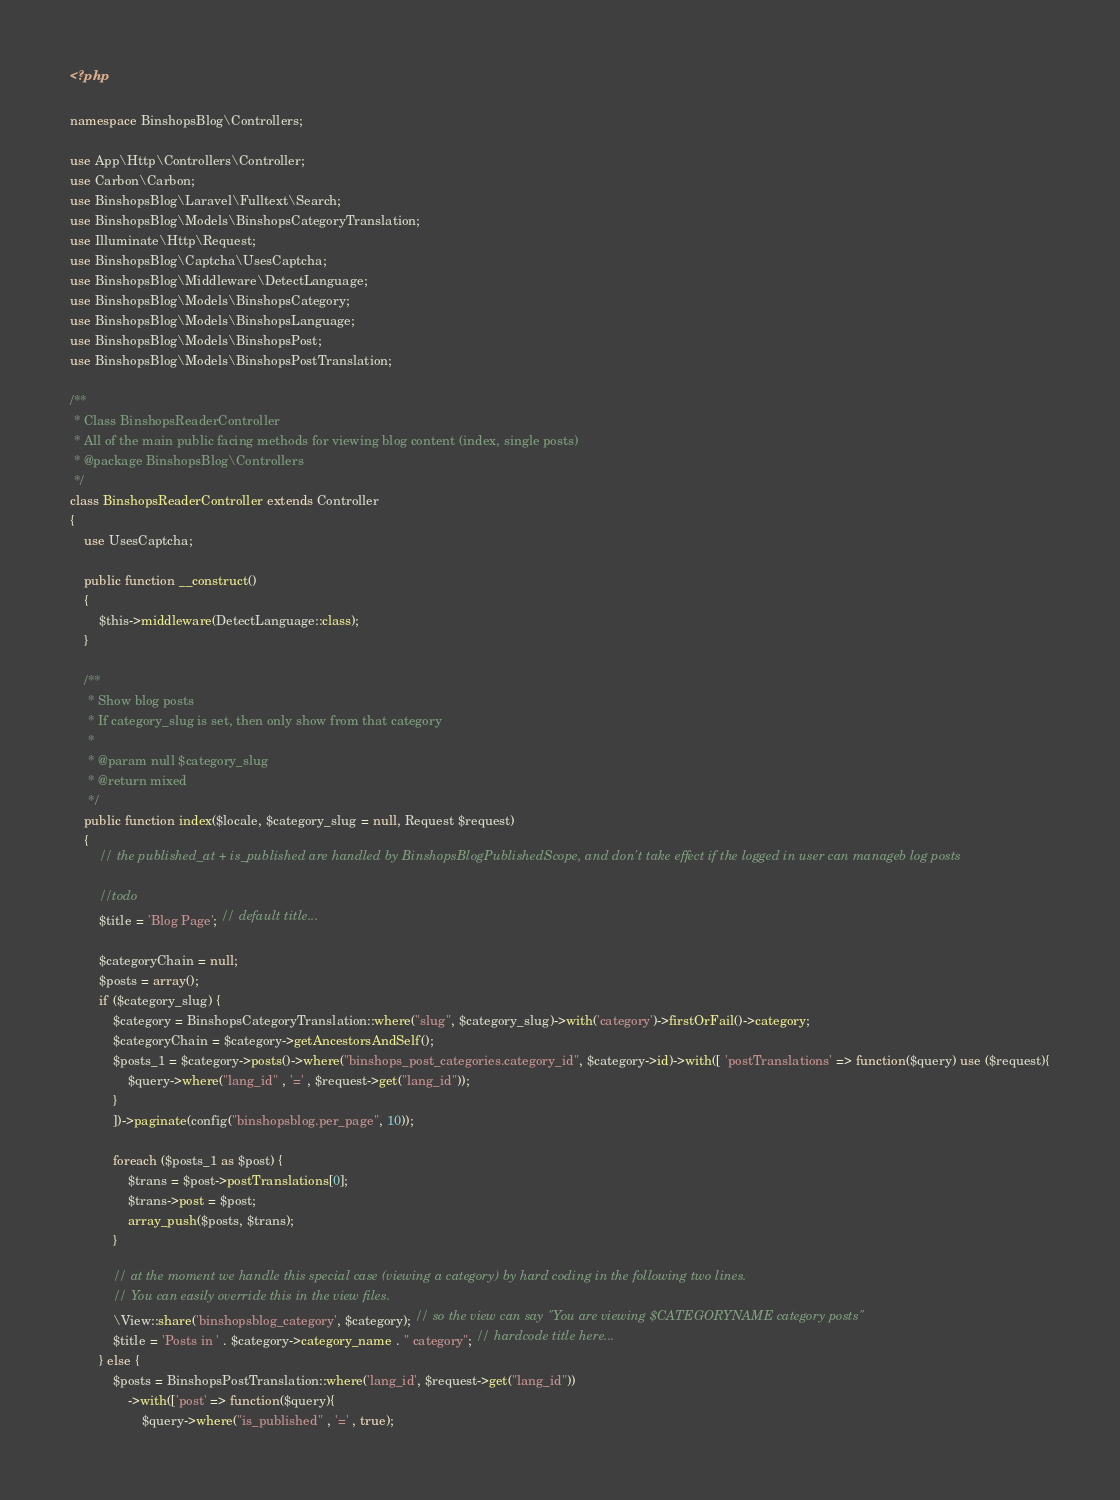<code> <loc_0><loc_0><loc_500><loc_500><_PHP_><?php

namespace BinshopsBlog\Controllers;

use App\Http\Controllers\Controller;
use Carbon\Carbon;
use BinshopsBlog\Laravel\Fulltext\Search;
use BinshopsBlog\Models\BinshopsCategoryTranslation;
use Illuminate\Http\Request;
use BinshopsBlog\Captcha\UsesCaptcha;
use BinshopsBlog\Middleware\DetectLanguage;
use BinshopsBlog\Models\BinshopsCategory;
use BinshopsBlog\Models\BinshopsLanguage;
use BinshopsBlog\Models\BinshopsPost;
use BinshopsBlog\Models\BinshopsPostTranslation;

/**
 * Class BinshopsReaderController
 * All of the main public facing methods for viewing blog content (index, single posts)
 * @package BinshopsBlog\Controllers
 */
class BinshopsReaderController extends Controller
{
    use UsesCaptcha;

    public function __construct()
    {
        $this->middleware(DetectLanguage::class);
    }

    /**
     * Show blog posts
     * If category_slug is set, then only show from that category
     *
     * @param null $category_slug
     * @return mixed
     */
    public function index($locale, $category_slug = null, Request $request)
    {
        // the published_at + is_published are handled by BinshopsBlogPublishedScope, and don't take effect if the logged in user can manageb log posts

        //todo
        $title = 'Blog Page'; // default title...

        $categoryChain = null;
        $posts = array();
        if ($category_slug) {
            $category = BinshopsCategoryTranslation::where("slug", $category_slug)->with('category')->firstOrFail()->category;
            $categoryChain = $category->getAncestorsAndSelf();
            $posts_1 = $category->posts()->where("binshops_post_categories.category_id", $category->id)->with([ 'postTranslations' => function($query) use ($request){
                $query->where("lang_id" , '=' , $request->get("lang_id"));
            }
            ])->paginate(config("binshopsblog.per_page", 10));

            foreach ($posts_1 as $post) {
                $trans = $post->postTranslations[0];
                $trans->post = $post;
                array_push($posts, $trans);
            }

            // at the moment we handle this special case (viewing a category) by hard coding in the following two lines.
            // You can easily override this in the view files.
            \View::share('binshopsblog_category', $category); // so the view can say "You are viewing $CATEGORYNAME category posts"
            $title = 'Posts in ' . $category->category_name . " category"; // hardcode title here...
        } else {
            $posts = BinshopsPostTranslation::where('lang_id', $request->get("lang_id"))
                ->with(['post' => function($query){
                    $query->where("is_published" , '=' , true);</code> 